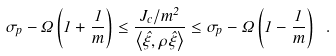Convert formula to latex. <formula><loc_0><loc_0><loc_500><loc_500>\sigma _ { p } - \Omega \left ( 1 + \frac { 1 } { m } \right ) \leq \frac { J _ { c } / m ^ { 2 } } { \left < \hat { \xi } , \rho \hat { \xi } \right > } \leq \sigma _ { p } - \Omega \left ( 1 - \frac { 1 } { m } \right ) \ .</formula> 